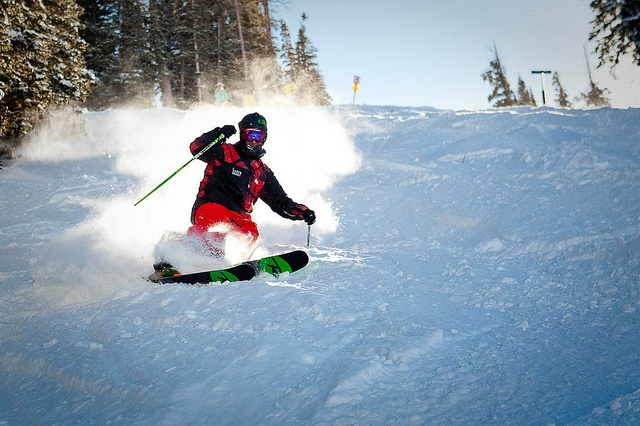Describe the objects in this image and their specific colors. I can see people in black, white, and brown tones and skis in black, darkgreen, green, and gray tones in this image. 